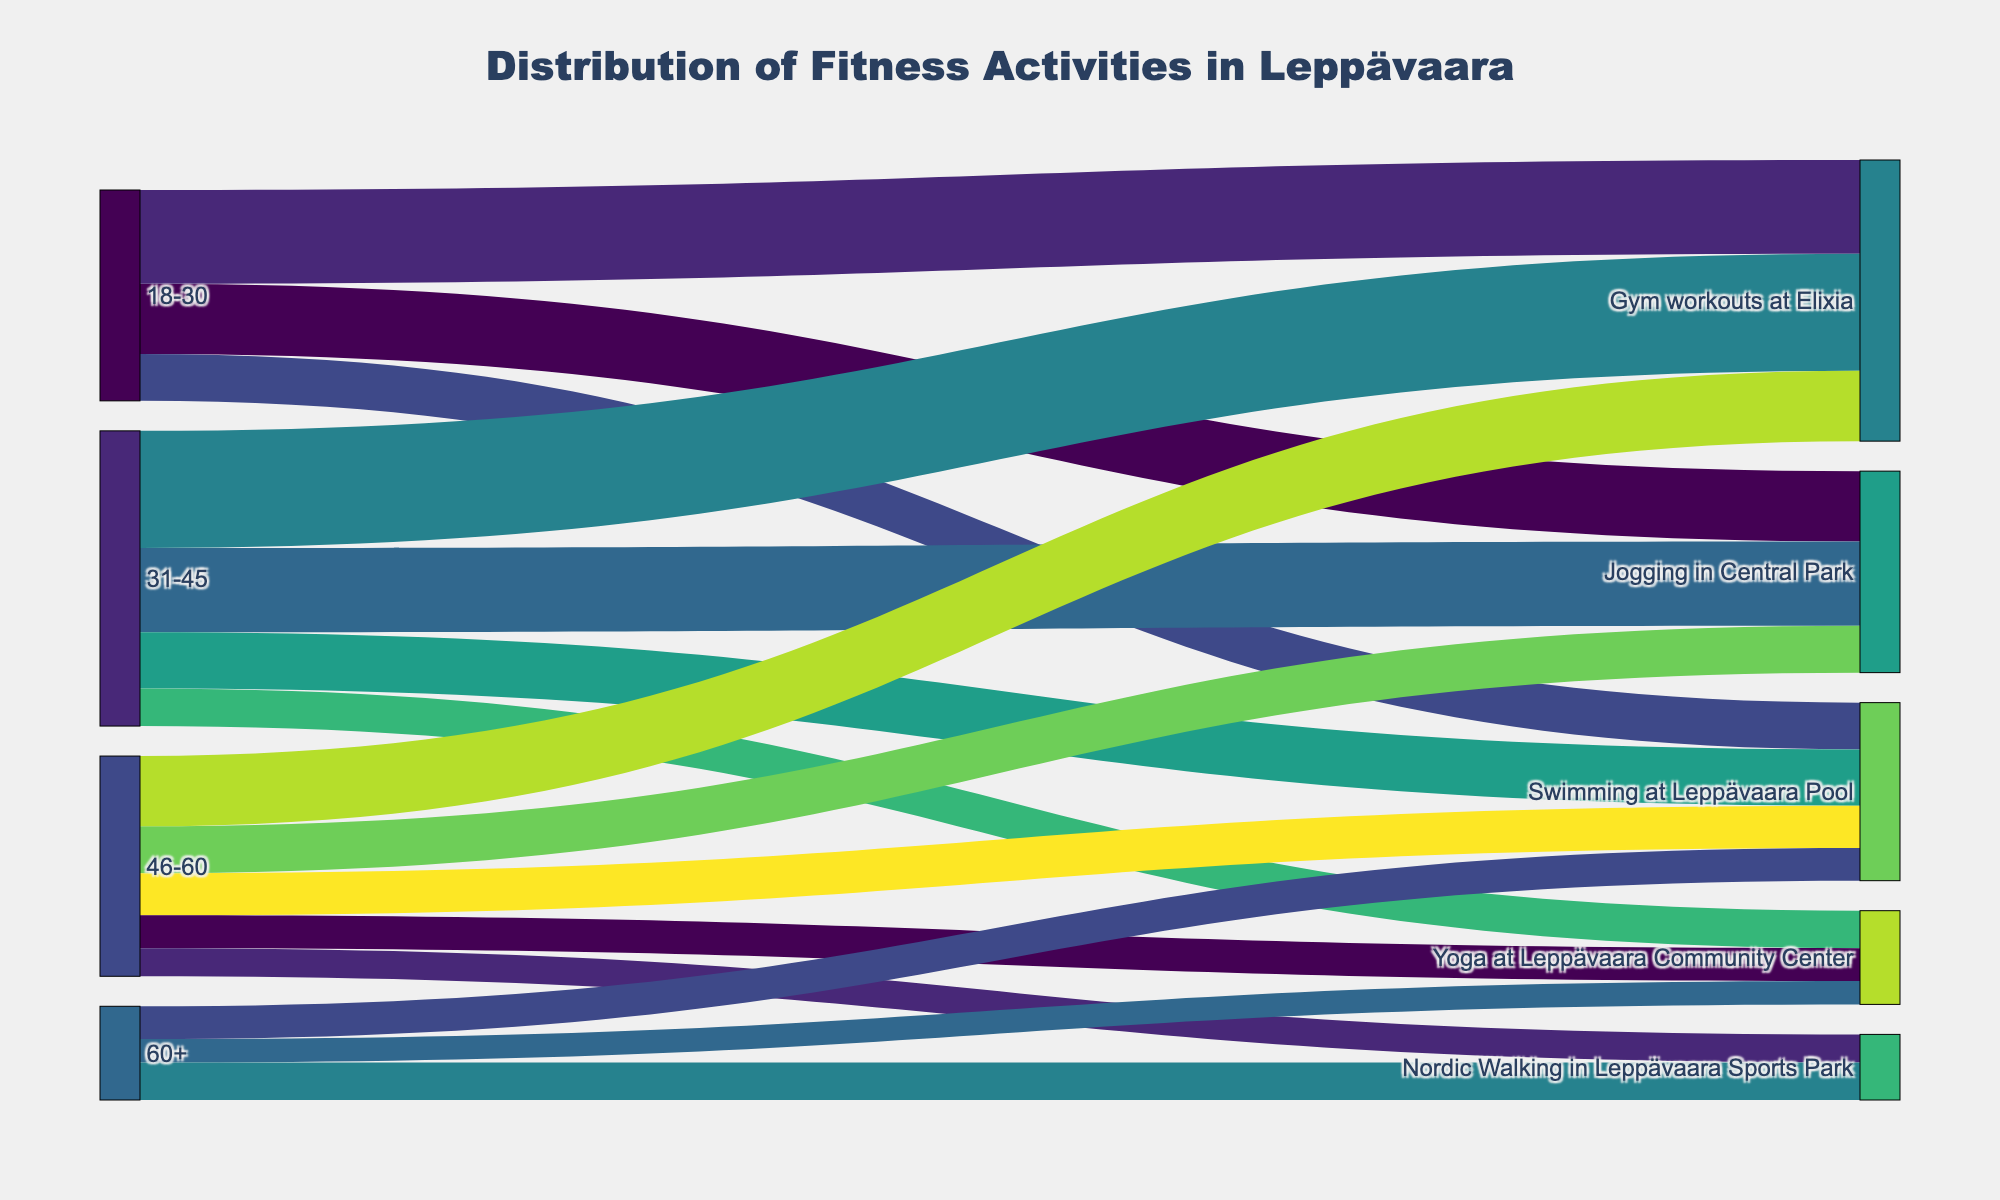Which fitness activity has the highest number of participants among 18-30 age group? By looking at the Sankey diagram, find the flow starting from "18-30" with the highest value. For the 18-30 age group, the largest number is for "Gym workouts at Elixia" with 200 participants.
Answer: Gym workouts at Elixia How many people aged 31-45 participate in Yoga at Leppävaara Community Center? Locate the flow from "31-45" to "Yoga at Leppävaara Community Center" and check the value of this flow in the Sankey diagram. The value is 80 individuals.
Answer: 80 Compare the number of participants in Swimming at Leppävaara Pool between the 18-30 and 31-45 age groups. Which age group has more participants? Locate the flows from both "18-30" and "31-45" to "Swimming at Leppävaara Pool" and compare their values, which are 100 and 120 respectively.
Answer: 31-45 What is the total number of people aged 46-60 participating in all the listed fitness activities? Sum the values of all flows originating from "46-60" by adding the following values: 100 (Jogging in Central Park), 150 (Gym workouts at Elixia), 90 (Swimming at Leppävaara Pool), 70 (Yoga at Leppävaara Community Center), 60 (Nordic Walking in Leppävaara Sports Park). The total is 470.
Answer: 470 Which age group has the least representation in Gym workouts at Elixia? Compare the numbers for "Gym workouts at Elixia" across all age groups. The values are: 200 (18-30), 250 (31-45), and 150 (46-60). The least representation is from the 46-60 age group.
Answer: 46-60 How does the participation in Yoga at Leppävaara Community Center compare between the 46-60 and 60+ age groups? Identify the values for "Yoga at Leppävaara Community Center" from both the 46-60 and 60+ age groups, which are 70 and 50 respectively.
Answer: 46-60 has more What is the most popular fitness activity for people aged 60+? Identify the flow from "60+" with the highest value. The options are 70 (Swimming at Leppävaara Pool), 50 (Yoga at Leppävaara Community Center), and 80 (Nordic Walking in Leppävaara Sports Park).
Answer: Nordic Walking in Leppävaara Sports Park Calculate the total number of participants in Jogging in Central Park across all age groups. Sum the values for "Jogging in Central Park" from all relevant age groups: 150 (18-30), 180 (31-45), 100 (46-60). The total is 430.
Answer: 430 